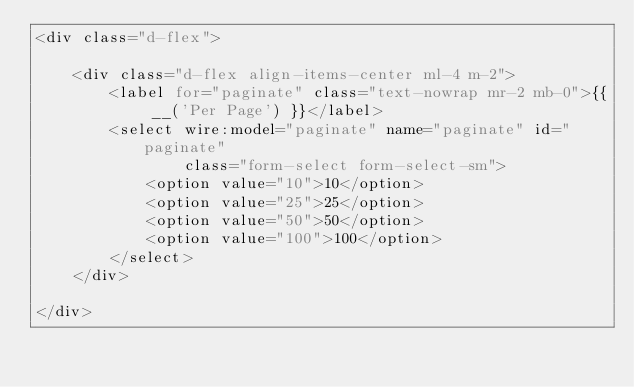Convert code to text. <code><loc_0><loc_0><loc_500><loc_500><_PHP_><div class="d-flex">

    <div class="d-flex align-items-center ml-4 m-2">
        <label for="paginate" class="text-nowrap mr-2 mb-0">{{ __('Per Page') }}</label>
        <select wire:model="paginate" name="paginate" id="paginate"
                class="form-select form-select-sm">
            <option value="10">10</option>
            <option value="25">25</option>
            <option value="50">50</option>
            <option value="100">100</option>
        </select>
    </div>

</div>
</code> 